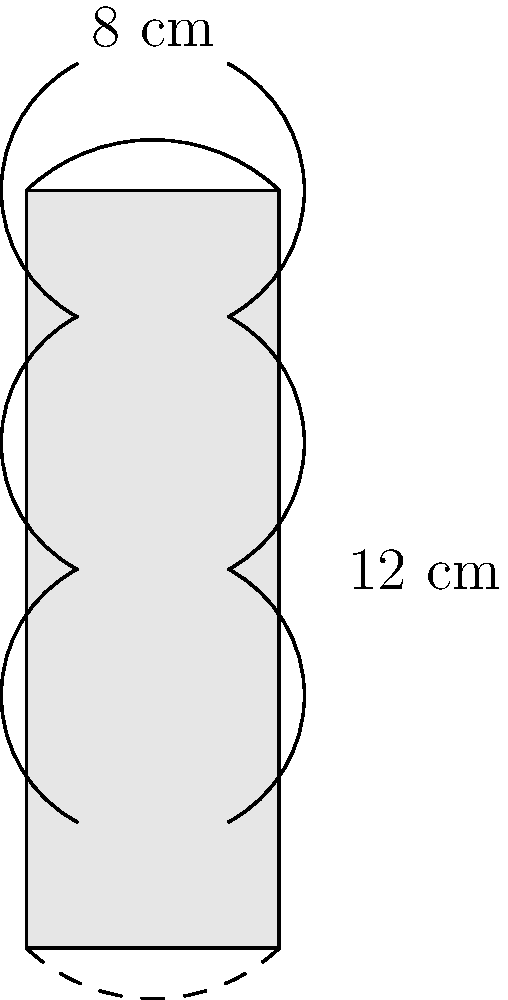You've acquired a beautifully etched cylindrical vase at a local estate sale. The vase measures 12 cm in height and has a diameter of 8 cm. What is the total surface area of the vase, including its circular top and bottom? Round your answer to the nearest square centimeter. To find the total surface area of the cylindrical vase, we need to calculate the area of the curved surface (lateral area) and add it to the areas of the circular top and bottom.

Step 1: Calculate the radius
The diameter is 8 cm, so the radius (r) is 4 cm.

Step 2: Calculate the lateral area
Lateral Area = $2\pi rh$, where $r$ is the radius and $h$ is the height
Lateral Area = $2\pi \cdot 4 \cdot 12 = 96\pi$ cm²

Step 3: Calculate the area of the circular top and bottom
Area of circle = $\pi r^2$
Area of one circular face = $\pi \cdot 4^2 = 16\pi$ cm²
Area of both circular faces = $2 \cdot 16\pi = 32\pi$ cm²

Step 4: Calculate the total surface area
Total Surface Area = Lateral Area + Area of both circular faces
Total Surface Area = $96\pi + 32\pi = 128\pi$ cm²

Step 5: Convert to a numerical value and round to the nearest square centimeter
Total Surface Area ≈ $128 \cdot 3.14159 \approx 402.12$ cm²
Rounded to the nearest square centimeter: 402 cm²
Answer: 402 cm² 